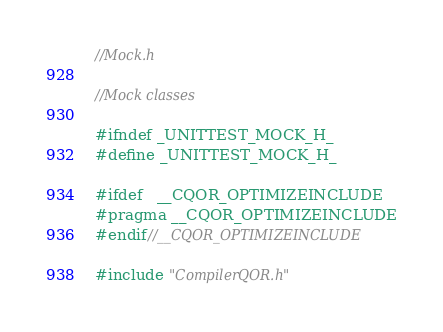Convert code to text. <code><loc_0><loc_0><loc_500><loc_500><_C_>//Mock.h

//Mock classes

#ifndef _UNITTEST_MOCK_H_
#define _UNITTEST_MOCK_H_

#ifdef	__CQOR_OPTIMIZEINCLUDE
#pragma __CQOR_OPTIMIZEINCLUDE
#endif//__CQOR_OPTIMIZEINCLUDE

#include "CompilerQOR.h"</code> 